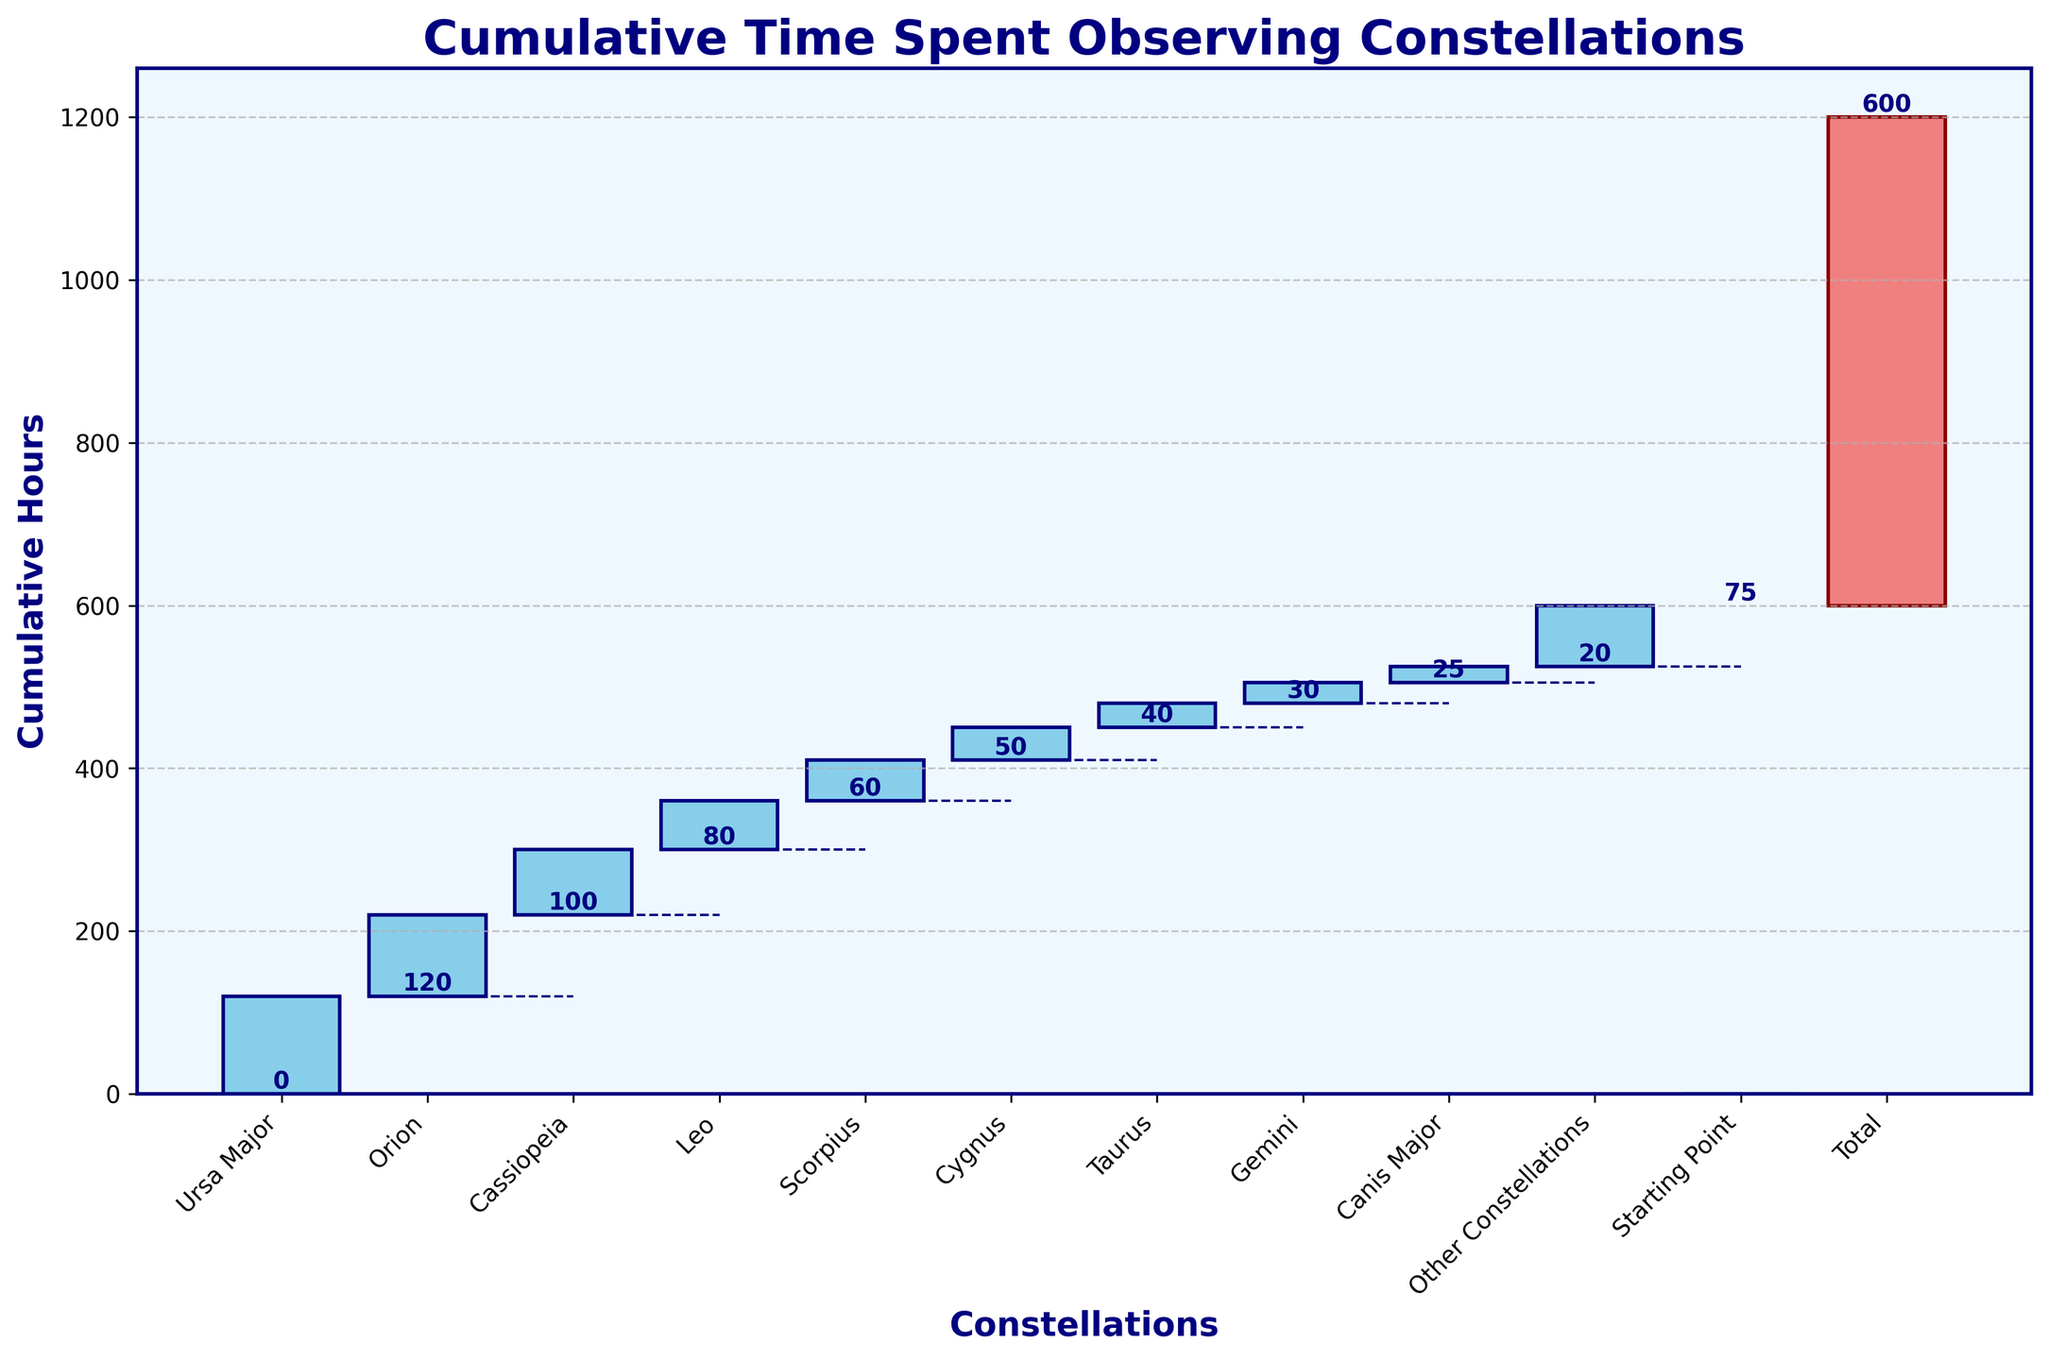How many constellations are listed in the chart? Count the number of constellation names displayed below the bars on the x-axis excluding "Starting Point" and "Total".
Answer: 10 What are the total hours spent on observing Ursa Major, Orion, and Cassiopeia combined? Add the hours spent on each, which are 120 (Ursa Major) + 100 (Orion) + 80 (Cassiopeia). The sum is 300.
Answer: 300 Which constellation did I spend the least hours observing and how many hours? Identify the bar with the smallest value after "Starting Point" but before "Total". It's Canis Major with 20 hours.
Answer: Canis Major, 20 What's the cumulative time spent observing constellations after including Leo? Look at the cumulative height of the bar labeled "Leo", noted above its top edge. It is 360 hours.
Answer: 360 How many more hours did I spend observing Ursa Major compared to Scorpius? Subtract the hours spent on Scorpius (50) from the hours spent on Ursa Major (120). The result is 70.
Answer: 70 What is the total duration indicated in the chart? The "Total" bar shows the cumulative time (the label at the top of the last bar). It states 600 hours.
Answer: 600 Does the cumulative time at Gemini exceed 500 hours? The cumulative height of the bar labeled "Gemini" is clearly shown below 500 hours, specifically 505 hours.
Answer: No Which constellations combined give a cumulative total close to 250 hours? Check the cumulative sums and find that after observing Cassiopeia (120 + 100 + 80), the cumulative total reaches 300. Thus, it's closer to 250 hours.
Answer: Ursa Major, Orion, Cassiopeia How much cumulative time is spent after observing Cygnus? Observe the total cumulative time directly after Cygnus, visible from the top of its bar. It reads 450 hours.
Answer: 450 